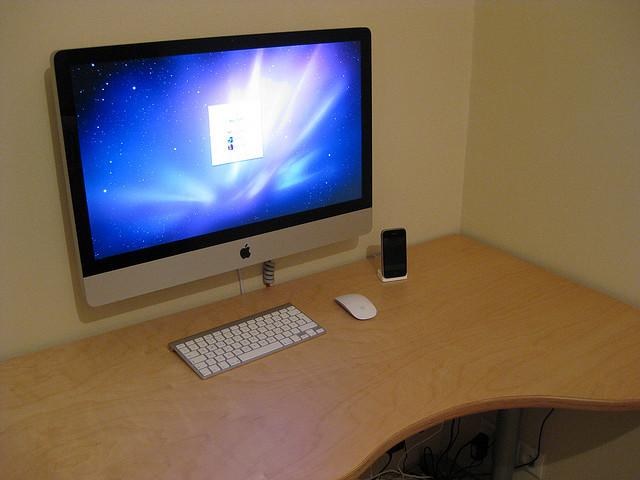Are there headphones?
Short answer required. No. Is this computer system missing a speaker?
Keep it brief. Yes. Is the mouse wireless?
Short answer required. Yes. What brand of computer is it?
Quick response, please. Apple. Is the desk clean?
Keep it brief. Yes. 